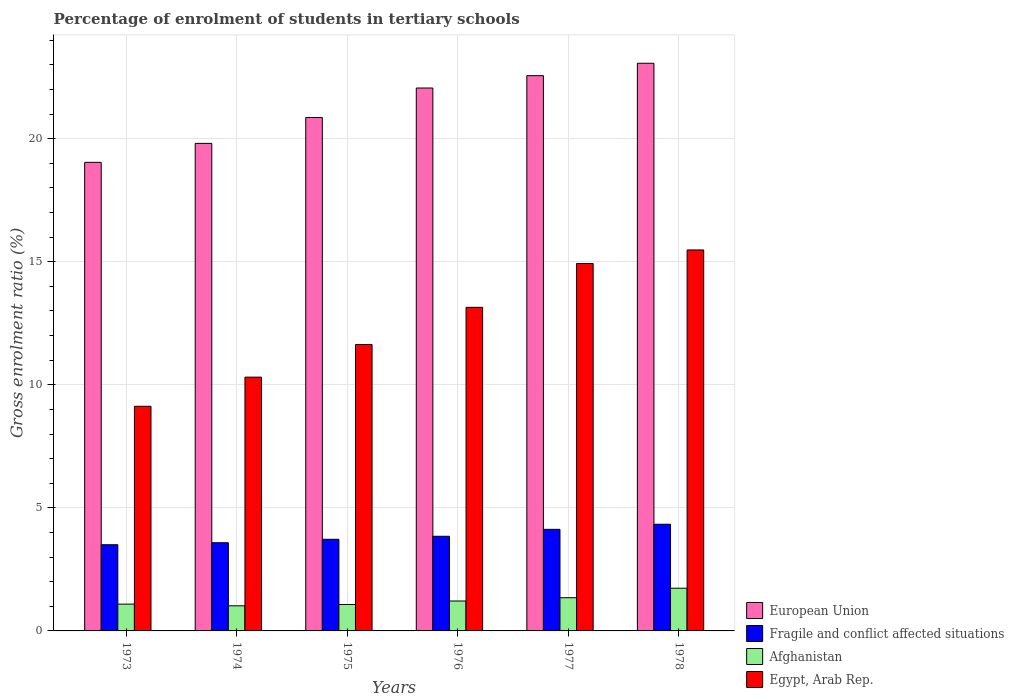How many different coloured bars are there?
Give a very brief answer. 4. How many bars are there on the 2nd tick from the left?
Provide a succinct answer. 4. What is the label of the 5th group of bars from the left?
Offer a terse response. 1977. In how many cases, is the number of bars for a given year not equal to the number of legend labels?
Your response must be concise. 0. What is the percentage of students enrolled in tertiary schools in European Union in 1973?
Your response must be concise. 19.04. Across all years, what is the maximum percentage of students enrolled in tertiary schools in European Union?
Offer a very short reply. 23.07. Across all years, what is the minimum percentage of students enrolled in tertiary schools in Afghanistan?
Provide a short and direct response. 1.02. In which year was the percentage of students enrolled in tertiary schools in Afghanistan maximum?
Provide a succinct answer. 1978. What is the total percentage of students enrolled in tertiary schools in Afghanistan in the graph?
Give a very brief answer. 7.48. What is the difference between the percentage of students enrolled in tertiary schools in European Union in 1974 and that in 1977?
Ensure brevity in your answer.  -2.75. What is the difference between the percentage of students enrolled in tertiary schools in European Union in 1977 and the percentage of students enrolled in tertiary schools in Fragile and conflict affected situations in 1974?
Offer a very short reply. 18.98. What is the average percentage of students enrolled in tertiary schools in Afghanistan per year?
Provide a short and direct response. 1.25. In the year 1974, what is the difference between the percentage of students enrolled in tertiary schools in Egypt, Arab Rep. and percentage of students enrolled in tertiary schools in Afghanistan?
Make the answer very short. 9.29. In how many years, is the percentage of students enrolled in tertiary schools in Egypt, Arab Rep. greater than 2 %?
Your answer should be very brief. 6. What is the ratio of the percentage of students enrolled in tertiary schools in Fragile and conflict affected situations in 1973 to that in 1974?
Keep it short and to the point. 0.98. Is the difference between the percentage of students enrolled in tertiary schools in Egypt, Arab Rep. in 1976 and 1977 greater than the difference between the percentage of students enrolled in tertiary schools in Afghanistan in 1976 and 1977?
Provide a succinct answer. No. What is the difference between the highest and the second highest percentage of students enrolled in tertiary schools in Egypt, Arab Rep.?
Offer a terse response. 0.55. What is the difference between the highest and the lowest percentage of students enrolled in tertiary schools in Fragile and conflict affected situations?
Keep it short and to the point. 0.83. Is the sum of the percentage of students enrolled in tertiary schools in Egypt, Arab Rep. in 1973 and 1976 greater than the maximum percentage of students enrolled in tertiary schools in Fragile and conflict affected situations across all years?
Offer a terse response. Yes. What does the 2nd bar from the left in 1974 represents?
Your response must be concise. Fragile and conflict affected situations. What does the 4th bar from the right in 1975 represents?
Your response must be concise. European Union. Are all the bars in the graph horizontal?
Your response must be concise. No. What is the difference between two consecutive major ticks on the Y-axis?
Ensure brevity in your answer.  5. Are the values on the major ticks of Y-axis written in scientific E-notation?
Make the answer very short. No. Does the graph contain any zero values?
Make the answer very short. No. Where does the legend appear in the graph?
Your answer should be compact. Bottom right. What is the title of the graph?
Your answer should be compact. Percentage of enrolment of students in tertiary schools. What is the label or title of the X-axis?
Offer a terse response. Years. What is the label or title of the Y-axis?
Offer a very short reply. Gross enrolment ratio (%). What is the Gross enrolment ratio (%) in European Union in 1973?
Provide a short and direct response. 19.04. What is the Gross enrolment ratio (%) in Fragile and conflict affected situations in 1973?
Offer a very short reply. 3.5. What is the Gross enrolment ratio (%) in Afghanistan in 1973?
Provide a succinct answer. 1.09. What is the Gross enrolment ratio (%) of Egypt, Arab Rep. in 1973?
Give a very brief answer. 9.13. What is the Gross enrolment ratio (%) of European Union in 1974?
Offer a very short reply. 19.81. What is the Gross enrolment ratio (%) in Fragile and conflict affected situations in 1974?
Your answer should be very brief. 3.58. What is the Gross enrolment ratio (%) of Afghanistan in 1974?
Offer a terse response. 1.02. What is the Gross enrolment ratio (%) of Egypt, Arab Rep. in 1974?
Your answer should be compact. 10.31. What is the Gross enrolment ratio (%) of European Union in 1975?
Your answer should be compact. 20.86. What is the Gross enrolment ratio (%) in Fragile and conflict affected situations in 1975?
Keep it short and to the point. 3.72. What is the Gross enrolment ratio (%) of Afghanistan in 1975?
Your answer should be very brief. 1.07. What is the Gross enrolment ratio (%) of Egypt, Arab Rep. in 1975?
Your response must be concise. 11.64. What is the Gross enrolment ratio (%) of European Union in 1976?
Your response must be concise. 22.06. What is the Gross enrolment ratio (%) in Fragile and conflict affected situations in 1976?
Make the answer very short. 3.85. What is the Gross enrolment ratio (%) in Afghanistan in 1976?
Your answer should be very brief. 1.22. What is the Gross enrolment ratio (%) in Egypt, Arab Rep. in 1976?
Make the answer very short. 13.15. What is the Gross enrolment ratio (%) of European Union in 1977?
Offer a very short reply. 22.56. What is the Gross enrolment ratio (%) in Fragile and conflict affected situations in 1977?
Keep it short and to the point. 4.13. What is the Gross enrolment ratio (%) of Afghanistan in 1977?
Provide a short and direct response. 1.35. What is the Gross enrolment ratio (%) in Egypt, Arab Rep. in 1977?
Give a very brief answer. 14.93. What is the Gross enrolment ratio (%) in European Union in 1978?
Give a very brief answer. 23.07. What is the Gross enrolment ratio (%) in Fragile and conflict affected situations in 1978?
Offer a terse response. 4.33. What is the Gross enrolment ratio (%) of Afghanistan in 1978?
Ensure brevity in your answer.  1.74. What is the Gross enrolment ratio (%) in Egypt, Arab Rep. in 1978?
Provide a short and direct response. 15.48. Across all years, what is the maximum Gross enrolment ratio (%) in European Union?
Your response must be concise. 23.07. Across all years, what is the maximum Gross enrolment ratio (%) in Fragile and conflict affected situations?
Provide a short and direct response. 4.33. Across all years, what is the maximum Gross enrolment ratio (%) of Afghanistan?
Keep it short and to the point. 1.74. Across all years, what is the maximum Gross enrolment ratio (%) of Egypt, Arab Rep.?
Give a very brief answer. 15.48. Across all years, what is the minimum Gross enrolment ratio (%) of European Union?
Keep it short and to the point. 19.04. Across all years, what is the minimum Gross enrolment ratio (%) in Fragile and conflict affected situations?
Ensure brevity in your answer.  3.5. Across all years, what is the minimum Gross enrolment ratio (%) of Afghanistan?
Offer a very short reply. 1.02. Across all years, what is the minimum Gross enrolment ratio (%) of Egypt, Arab Rep.?
Give a very brief answer. 9.13. What is the total Gross enrolment ratio (%) of European Union in the graph?
Provide a short and direct response. 127.4. What is the total Gross enrolment ratio (%) of Fragile and conflict affected situations in the graph?
Provide a short and direct response. 23.12. What is the total Gross enrolment ratio (%) in Afghanistan in the graph?
Your response must be concise. 7.48. What is the total Gross enrolment ratio (%) of Egypt, Arab Rep. in the graph?
Your answer should be very brief. 74.64. What is the difference between the Gross enrolment ratio (%) of European Union in 1973 and that in 1974?
Your answer should be compact. -0.77. What is the difference between the Gross enrolment ratio (%) of Fragile and conflict affected situations in 1973 and that in 1974?
Provide a succinct answer. -0.08. What is the difference between the Gross enrolment ratio (%) of Afghanistan in 1973 and that in 1974?
Ensure brevity in your answer.  0.07. What is the difference between the Gross enrolment ratio (%) of Egypt, Arab Rep. in 1973 and that in 1974?
Offer a very short reply. -1.18. What is the difference between the Gross enrolment ratio (%) in European Union in 1973 and that in 1975?
Ensure brevity in your answer.  -1.82. What is the difference between the Gross enrolment ratio (%) of Fragile and conflict affected situations in 1973 and that in 1975?
Provide a succinct answer. -0.22. What is the difference between the Gross enrolment ratio (%) in Afghanistan in 1973 and that in 1975?
Give a very brief answer. 0.02. What is the difference between the Gross enrolment ratio (%) in Egypt, Arab Rep. in 1973 and that in 1975?
Your answer should be compact. -2.51. What is the difference between the Gross enrolment ratio (%) of European Union in 1973 and that in 1976?
Your response must be concise. -3.02. What is the difference between the Gross enrolment ratio (%) in Fragile and conflict affected situations in 1973 and that in 1976?
Make the answer very short. -0.34. What is the difference between the Gross enrolment ratio (%) in Afghanistan in 1973 and that in 1976?
Give a very brief answer. -0.13. What is the difference between the Gross enrolment ratio (%) in Egypt, Arab Rep. in 1973 and that in 1976?
Provide a short and direct response. -4.02. What is the difference between the Gross enrolment ratio (%) of European Union in 1973 and that in 1977?
Ensure brevity in your answer.  -3.52. What is the difference between the Gross enrolment ratio (%) in Fragile and conflict affected situations in 1973 and that in 1977?
Provide a short and direct response. -0.62. What is the difference between the Gross enrolment ratio (%) in Afghanistan in 1973 and that in 1977?
Provide a succinct answer. -0.26. What is the difference between the Gross enrolment ratio (%) in Egypt, Arab Rep. in 1973 and that in 1977?
Your response must be concise. -5.8. What is the difference between the Gross enrolment ratio (%) of European Union in 1973 and that in 1978?
Offer a very short reply. -4.03. What is the difference between the Gross enrolment ratio (%) of Fragile and conflict affected situations in 1973 and that in 1978?
Offer a terse response. -0.83. What is the difference between the Gross enrolment ratio (%) of Afghanistan in 1973 and that in 1978?
Offer a very short reply. -0.65. What is the difference between the Gross enrolment ratio (%) in Egypt, Arab Rep. in 1973 and that in 1978?
Provide a succinct answer. -6.35. What is the difference between the Gross enrolment ratio (%) of European Union in 1974 and that in 1975?
Offer a terse response. -1.05. What is the difference between the Gross enrolment ratio (%) in Fragile and conflict affected situations in 1974 and that in 1975?
Your answer should be very brief. -0.14. What is the difference between the Gross enrolment ratio (%) of Afghanistan in 1974 and that in 1975?
Provide a short and direct response. -0.05. What is the difference between the Gross enrolment ratio (%) of Egypt, Arab Rep. in 1974 and that in 1975?
Provide a succinct answer. -1.33. What is the difference between the Gross enrolment ratio (%) in European Union in 1974 and that in 1976?
Your answer should be compact. -2.25. What is the difference between the Gross enrolment ratio (%) of Fragile and conflict affected situations in 1974 and that in 1976?
Provide a succinct answer. -0.26. What is the difference between the Gross enrolment ratio (%) of Afghanistan in 1974 and that in 1976?
Provide a succinct answer. -0.2. What is the difference between the Gross enrolment ratio (%) in Egypt, Arab Rep. in 1974 and that in 1976?
Your answer should be very brief. -2.84. What is the difference between the Gross enrolment ratio (%) in European Union in 1974 and that in 1977?
Offer a very short reply. -2.75. What is the difference between the Gross enrolment ratio (%) of Fragile and conflict affected situations in 1974 and that in 1977?
Your answer should be very brief. -0.54. What is the difference between the Gross enrolment ratio (%) of Afghanistan in 1974 and that in 1977?
Provide a succinct answer. -0.33. What is the difference between the Gross enrolment ratio (%) of Egypt, Arab Rep. in 1974 and that in 1977?
Offer a terse response. -4.62. What is the difference between the Gross enrolment ratio (%) in European Union in 1974 and that in 1978?
Keep it short and to the point. -3.26. What is the difference between the Gross enrolment ratio (%) of Fragile and conflict affected situations in 1974 and that in 1978?
Provide a short and direct response. -0.75. What is the difference between the Gross enrolment ratio (%) of Afghanistan in 1974 and that in 1978?
Offer a terse response. -0.72. What is the difference between the Gross enrolment ratio (%) in Egypt, Arab Rep. in 1974 and that in 1978?
Ensure brevity in your answer.  -5.17. What is the difference between the Gross enrolment ratio (%) of European Union in 1975 and that in 1976?
Your answer should be very brief. -1.2. What is the difference between the Gross enrolment ratio (%) in Fragile and conflict affected situations in 1975 and that in 1976?
Your answer should be compact. -0.12. What is the difference between the Gross enrolment ratio (%) of Afghanistan in 1975 and that in 1976?
Make the answer very short. -0.14. What is the difference between the Gross enrolment ratio (%) in Egypt, Arab Rep. in 1975 and that in 1976?
Your answer should be compact. -1.51. What is the difference between the Gross enrolment ratio (%) of European Union in 1975 and that in 1977?
Your answer should be compact. -1.7. What is the difference between the Gross enrolment ratio (%) of Fragile and conflict affected situations in 1975 and that in 1977?
Ensure brevity in your answer.  -0.4. What is the difference between the Gross enrolment ratio (%) of Afghanistan in 1975 and that in 1977?
Keep it short and to the point. -0.28. What is the difference between the Gross enrolment ratio (%) in Egypt, Arab Rep. in 1975 and that in 1977?
Offer a terse response. -3.29. What is the difference between the Gross enrolment ratio (%) of European Union in 1975 and that in 1978?
Provide a succinct answer. -2.2. What is the difference between the Gross enrolment ratio (%) in Fragile and conflict affected situations in 1975 and that in 1978?
Make the answer very short. -0.61. What is the difference between the Gross enrolment ratio (%) of Afghanistan in 1975 and that in 1978?
Your answer should be compact. -0.66. What is the difference between the Gross enrolment ratio (%) in Egypt, Arab Rep. in 1975 and that in 1978?
Offer a terse response. -3.84. What is the difference between the Gross enrolment ratio (%) in European Union in 1976 and that in 1977?
Your response must be concise. -0.5. What is the difference between the Gross enrolment ratio (%) in Fragile and conflict affected situations in 1976 and that in 1977?
Offer a terse response. -0.28. What is the difference between the Gross enrolment ratio (%) in Afghanistan in 1976 and that in 1977?
Keep it short and to the point. -0.13. What is the difference between the Gross enrolment ratio (%) in Egypt, Arab Rep. in 1976 and that in 1977?
Your answer should be compact. -1.78. What is the difference between the Gross enrolment ratio (%) in European Union in 1976 and that in 1978?
Keep it short and to the point. -1.01. What is the difference between the Gross enrolment ratio (%) in Fragile and conflict affected situations in 1976 and that in 1978?
Your answer should be compact. -0.49. What is the difference between the Gross enrolment ratio (%) of Afghanistan in 1976 and that in 1978?
Provide a short and direct response. -0.52. What is the difference between the Gross enrolment ratio (%) in Egypt, Arab Rep. in 1976 and that in 1978?
Your answer should be very brief. -2.33. What is the difference between the Gross enrolment ratio (%) in European Union in 1977 and that in 1978?
Make the answer very short. -0.5. What is the difference between the Gross enrolment ratio (%) of Fragile and conflict affected situations in 1977 and that in 1978?
Provide a succinct answer. -0.21. What is the difference between the Gross enrolment ratio (%) in Afghanistan in 1977 and that in 1978?
Provide a succinct answer. -0.39. What is the difference between the Gross enrolment ratio (%) in Egypt, Arab Rep. in 1977 and that in 1978?
Make the answer very short. -0.55. What is the difference between the Gross enrolment ratio (%) in European Union in 1973 and the Gross enrolment ratio (%) in Fragile and conflict affected situations in 1974?
Your answer should be very brief. 15.46. What is the difference between the Gross enrolment ratio (%) in European Union in 1973 and the Gross enrolment ratio (%) in Afghanistan in 1974?
Your answer should be very brief. 18.02. What is the difference between the Gross enrolment ratio (%) in European Union in 1973 and the Gross enrolment ratio (%) in Egypt, Arab Rep. in 1974?
Your answer should be very brief. 8.73. What is the difference between the Gross enrolment ratio (%) of Fragile and conflict affected situations in 1973 and the Gross enrolment ratio (%) of Afghanistan in 1974?
Provide a succinct answer. 2.48. What is the difference between the Gross enrolment ratio (%) of Fragile and conflict affected situations in 1973 and the Gross enrolment ratio (%) of Egypt, Arab Rep. in 1974?
Your response must be concise. -6.81. What is the difference between the Gross enrolment ratio (%) in Afghanistan in 1973 and the Gross enrolment ratio (%) in Egypt, Arab Rep. in 1974?
Your response must be concise. -9.22. What is the difference between the Gross enrolment ratio (%) of European Union in 1973 and the Gross enrolment ratio (%) of Fragile and conflict affected situations in 1975?
Your response must be concise. 15.32. What is the difference between the Gross enrolment ratio (%) in European Union in 1973 and the Gross enrolment ratio (%) in Afghanistan in 1975?
Your answer should be very brief. 17.97. What is the difference between the Gross enrolment ratio (%) in European Union in 1973 and the Gross enrolment ratio (%) in Egypt, Arab Rep. in 1975?
Make the answer very short. 7.4. What is the difference between the Gross enrolment ratio (%) of Fragile and conflict affected situations in 1973 and the Gross enrolment ratio (%) of Afghanistan in 1975?
Provide a succinct answer. 2.43. What is the difference between the Gross enrolment ratio (%) in Fragile and conflict affected situations in 1973 and the Gross enrolment ratio (%) in Egypt, Arab Rep. in 1975?
Your answer should be very brief. -8.13. What is the difference between the Gross enrolment ratio (%) in Afghanistan in 1973 and the Gross enrolment ratio (%) in Egypt, Arab Rep. in 1975?
Provide a short and direct response. -10.55. What is the difference between the Gross enrolment ratio (%) in European Union in 1973 and the Gross enrolment ratio (%) in Fragile and conflict affected situations in 1976?
Your response must be concise. 15.19. What is the difference between the Gross enrolment ratio (%) in European Union in 1973 and the Gross enrolment ratio (%) in Afghanistan in 1976?
Provide a succinct answer. 17.82. What is the difference between the Gross enrolment ratio (%) of European Union in 1973 and the Gross enrolment ratio (%) of Egypt, Arab Rep. in 1976?
Your response must be concise. 5.89. What is the difference between the Gross enrolment ratio (%) of Fragile and conflict affected situations in 1973 and the Gross enrolment ratio (%) of Afghanistan in 1976?
Your answer should be very brief. 2.29. What is the difference between the Gross enrolment ratio (%) in Fragile and conflict affected situations in 1973 and the Gross enrolment ratio (%) in Egypt, Arab Rep. in 1976?
Provide a short and direct response. -9.65. What is the difference between the Gross enrolment ratio (%) of Afghanistan in 1973 and the Gross enrolment ratio (%) of Egypt, Arab Rep. in 1976?
Your answer should be very brief. -12.06. What is the difference between the Gross enrolment ratio (%) in European Union in 1973 and the Gross enrolment ratio (%) in Fragile and conflict affected situations in 1977?
Ensure brevity in your answer.  14.91. What is the difference between the Gross enrolment ratio (%) of European Union in 1973 and the Gross enrolment ratio (%) of Afghanistan in 1977?
Provide a short and direct response. 17.69. What is the difference between the Gross enrolment ratio (%) of European Union in 1973 and the Gross enrolment ratio (%) of Egypt, Arab Rep. in 1977?
Provide a succinct answer. 4.11. What is the difference between the Gross enrolment ratio (%) in Fragile and conflict affected situations in 1973 and the Gross enrolment ratio (%) in Afghanistan in 1977?
Make the answer very short. 2.15. What is the difference between the Gross enrolment ratio (%) in Fragile and conflict affected situations in 1973 and the Gross enrolment ratio (%) in Egypt, Arab Rep. in 1977?
Offer a terse response. -11.43. What is the difference between the Gross enrolment ratio (%) of Afghanistan in 1973 and the Gross enrolment ratio (%) of Egypt, Arab Rep. in 1977?
Your response must be concise. -13.84. What is the difference between the Gross enrolment ratio (%) in European Union in 1973 and the Gross enrolment ratio (%) in Fragile and conflict affected situations in 1978?
Offer a very short reply. 14.71. What is the difference between the Gross enrolment ratio (%) of European Union in 1973 and the Gross enrolment ratio (%) of Afghanistan in 1978?
Provide a short and direct response. 17.3. What is the difference between the Gross enrolment ratio (%) of European Union in 1973 and the Gross enrolment ratio (%) of Egypt, Arab Rep. in 1978?
Give a very brief answer. 3.56. What is the difference between the Gross enrolment ratio (%) in Fragile and conflict affected situations in 1973 and the Gross enrolment ratio (%) in Afghanistan in 1978?
Your response must be concise. 1.77. What is the difference between the Gross enrolment ratio (%) of Fragile and conflict affected situations in 1973 and the Gross enrolment ratio (%) of Egypt, Arab Rep. in 1978?
Provide a succinct answer. -11.98. What is the difference between the Gross enrolment ratio (%) of Afghanistan in 1973 and the Gross enrolment ratio (%) of Egypt, Arab Rep. in 1978?
Your answer should be compact. -14.39. What is the difference between the Gross enrolment ratio (%) in European Union in 1974 and the Gross enrolment ratio (%) in Fragile and conflict affected situations in 1975?
Keep it short and to the point. 16.09. What is the difference between the Gross enrolment ratio (%) of European Union in 1974 and the Gross enrolment ratio (%) of Afghanistan in 1975?
Give a very brief answer. 18.74. What is the difference between the Gross enrolment ratio (%) of European Union in 1974 and the Gross enrolment ratio (%) of Egypt, Arab Rep. in 1975?
Keep it short and to the point. 8.17. What is the difference between the Gross enrolment ratio (%) in Fragile and conflict affected situations in 1974 and the Gross enrolment ratio (%) in Afghanistan in 1975?
Give a very brief answer. 2.51. What is the difference between the Gross enrolment ratio (%) of Fragile and conflict affected situations in 1974 and the Gross enrolment ratio (%) of Egypt, Arab Rep. in 1975?
Provide a succinct answer. -8.05. What is the difference between the Gross enrolment ratio (%) in Afghanistan in 1974 and the Gross enrolment ratio (%) in Egypt, Arab Rep. in 1975?
Provide a succinct answer. -10.62. What is the difference between the Gross enrolment ratio (%) of European Union in 1974 and the Gross enrolment ratio (%) of Fragile and conflict affected situations in 1976?
Keep it short and to the point. 15.96. What is the difference between the Gross enrolment ratio (%) of European Union in 1974 and the Gross enrolment ratio (%) of Afghanistan in 1976?
Give a very brief answer. 18.6. What is the difference between the Gross enrolment ratio (%) in European Union in 1974 and the Gross enrolment ratio (%) in Egypt, Arab Rep. in 1976?
Ensure brevity in your answer.  6.66. What is the difference between the Gross enrolment ratio (%) of Fragile and conflict affected situations in 1974 and the Gross enrolment ratio (%) of Afghanistan in 1976?
Your response must be concise. 2.37. What is the difference between the Gross enrolment ratio (%) in Fragile and conflict affected situations in 1974 and the Gross enrolment ratio (%) in Egypt, Arab Rep. in 1976?
Your response must be concise. -9.57. What is the difference between the Gross enrolment ratio (%) in Afghanistan in 1974 and the Gross enrolment ratio (%) in Egypt, Arab Rep. in 1976?
Provide a short and direct response. -12.13. What is the difference between the Gross enrolment ratio (%) of European Union in 1974 and the Gross enrolment ratio (%) of Fragile and conflict affected situations in 1977?
Offer a very short reply. 15.68. What is the difference between the Gross enrolment ratio (%) in European Union in 1974 and the Gross enrolment ratio (%) in Afghanistan in 1977?
Provide a short and direct response. 18.46. What is the difference between the Gross enrolment ratio (%) in European Union in 1974 and the Gross enrolment ratio (%) in Egypt, Arab Rep. in 1977?
Offer a terse response. 4.88. What is the difference between the Gross enrolment ratio (%) in Fragile and conflict affected situations in 1974 and the Gross enrolment ratio (%) in Afghanistan in 1977?
Your answer should be compact. 2.23. What is the difference between the Gross enrolment ratio (%) in Fragile and conflict affected situations in 1974 and the Gross enrolment ratio (%) in Egypt, Arab Rep. in 1977?
Your response must be concise. -11.35. What is the difference between the Gross enrolment ratio (%) in Afghanistan in 1974 and the Gross enrolment ratio (%) in Egypt, Arab Rep. in 1977?
Your response must be concise. -13.91. What is the difference between the Gross enrolment ratio (%) of European Union in 1974 and the Gross enrolment ratio (%) of Fragile and conflict affected situations in 1978?
Make the answer very short. 15.48. What is the difference between the Gross enrolment ratio (%) of European Union in 1974 and the Gross enrolment ratio (%) of Afghanistan in 1978?
Your answer should be compact. 18.08. What is the difference between the Gross enrolment ratio (%) of European Union in 1974 and the Gross enrolment ratio (%) of Egypt, Arab Rep. in 1978?
Give a very brief answer. 4.33. What is the difference between the Gross enrolment ratio (%) in Fragile and conflict affected situations in 1974 and the Gross enrolment ratio (%) in Afghanistan in 1978?
Your answer should be compact. 1.85. What is the difference between the Gross enrolment ratio (%) of Fragile and conflict affected situations in 1974 and the Gross enrolment ratio (%) of Egypt, Arab Rep. in 1978?
Offer a very short reply. -11.9. What is the difference between the Gross enrolment ratio (%) in Afghanistan in 1974 and the Gross enrolment ratio (%) in Egypt, Arab Rep. in 1978?
Offer a very short reply. -14.46. What is the difference between the Gross enrolment ratio (%) in European Union in 1975 and the Gross enrolment ratio (%) in Fragile and conflict affected situations in 1976?
Your response must be concise. 17.02. What is the difference between the Gross enrolment ratio (%) in European Union in 1975 and the Gross enrolment ratio (%) in Afghanistan in 1976?
Give a very brief answer. 19.65. What is the difference between the Gross enrolment ratio (%) in European Union in 1975 and the Gross enrolment ratio (%) in Egypt, Arab Rep. in 1976?
Give a very brief answer. 7.71. What is the difference between the Gross enrolment ratio (%) of Fragile and conflict affected situations in 1975 and the Gross enrolment ratio (%) of Afghanistan in 1976?
Keep it short and to the point. 2.51. What is the difference between the Gross enrolment ratio (%) of Fragile and conflict affected situations in 1975 and the Gross enrolment ratio (%) of Egypt, Arab Rep. in 1976?
Ensure brevity in your answer.  -9.42. What is the difference between the Gross enrolment ratio (%) in Afghanistan in 1975 and the Gross enrolment ratio (%) in Egypt, Arab Rep. in 1976?
Give a very brief answer. -12.07. What is the difference between the Gross enrolment ratio (%) of European Union in 1975 and the Gross enrolment ratio (%) of Fragile and conflict affected situations in 1977?
Your response must be concise. 16.74. What is the difference between the Gross enrolment ratio (%) of European Union in 1975 and the Gross enrolment ratio (%) of Afghanistan in 1977?
Your answer should be compact. 19.51. What is the difference between the Gross enrolment ratio (%) of European Union in 1975 and the Gross enrolment ratio (%) of Egypt, Arab Rep. in 1977?
Provide a short and direct response. 5.93. What is the difference between the Gross enrolment ratio (%) in Fragile and conflict affected situations in 1975 and the Gross enrolment ratio (%) in Afghanistan in 1977?
Ensure brevity in your answer.  2.37. What is the difference between the Gross enrolment ratio (%) in Fragile and conflict affected situations in 1975 and the Gross enrolment ratio (%) in Egypt, Arab Rep. in 1977?
Provide a short and direct response. -11.21. What is the difference between the Gross enrolment ratio (%) in Afghanistan in 1975 and the Gross enrolment ratio (%) in Egypt, Arab Rep. in 1977?
Keep it short and to the point. -13.86. What is the difference between the Gross enrolment ratio (%) of European Union in 1975 and the Gross enrolment ratio (%) of Fragile and conflict affected situations in 1978?
Offer a terse response. 16.53. What is the difference between the Gross enrolment ratio (%) of European Union in 1975 and the Gross enrolment ratio (%) of Afghanistan in 1978?
Offer a very short reply. 19.13. What is the difference between the Gross enrolment ratio (%) of European Union in 1975 and the Gross enrolment ratio (%) of Egypt, Arab Rep. in 1978?
Provide a short and direct response. 5.38. What is the difference between the Gross enrolment ratio (%) of Fragile and conflict affected situations in 1975 and the Gross enrolment ratio (%) of Afghanistan in 1978?
Your answer should be compact. 1.99. What is the difference between the Gross enrolment ratio (%) of Fragile and conflict affected situations in 1975 and the Gross enrolment ratio (%) of Egypt, Arab Rep. in 1978?
Give a very brief answer. -11.76. What is the difference between the Gross enrolment ratio (%) in Afghanistan in 1975 and the Gross enrolment ratio (%) in Egypt, Arab Rep. in 1978?
Make the answer very short. -14.41. What is the difference between the Gross enrolment ratio (%) in European Union in 1976 and the Gross enrolment ratio (%) in Fragile and conflict affected situations in 1977?
Your response must be concise. 17.93. What is the difference between the Gross enrolment ratio (%) of European Union in 1976 and the Gross enrolment ratio (%) of Afghanistan in 1977?
Make the answer very short. 20.71. What is the difference between the Gross enrolment ratio (%) of European Union in 1976 and the Gross enrolment ratio (%) of Egypt, Arab Rep. in 1977?
Offer a very short reply. 7.13. What is the difference between the Gross enrolment ratio (%) of Fragile and conflict affected situations in 1976 and the Gross enrolment ratio (%) of Afghanistan in 1977?
Keep it short and to the point. 2.5. What is the difference between the Gross enrolment ratio (%) in Fragile and conflict affected situations in 1976 and the Gross enrolment ratio (%) in Egypt, Arab Rep. in 1977?
Keep it short and to the point. -11.08. What is the difference between the Gross enrolment ratio (%) of Afghanistan in 1976 and the Gross enrolment ratio (%) of Egypt, Arab Rep. in 1977?
Your answer should be very brief. -13.71. What is the difference between the Gross enrolment ratio (%) of European Union in 1976 and the Gross enrolment ratio (%) of Fragile and conflict affected situations in 1978?
Keep it short and to the point. 17.73. What is the difference between the Gross enrolment ratio (%) in European Union in 1976 and the Gross enrolment ratio (%) in Afghanistan in 1978?
Make the answer very short. 20.33. What is the difference between the Gross enrolment ratio (%) in European Union in 1976 and the Gross enrolment ratio (%) in Egypt, Arab Rep. in 1978?
Provide a short and direct response. 6.58. What is the difference between the Gross enrolment ratio (%) in Fragile and conflict affected situations in 1976 and the Gross enrolment ratio (%) in Afghanistan in 1978?
Your response must be concise. 2.11. What is the difference between the Gross enrolment ratio (%) in Fragile and conflict affected situations in 1976 and the Gross enrolment ratio (%) in Egypt, Arab Rep. in 1978?
Your answer should be very brief. -11.63. What is the difference between the Gross enrolment ratio (%) of Afghanistan in 1976 and the Gross enrolment ratio (%) of Egypt, Arab Rep. in 1978?
Offer a very short reply. -14.27. What is the difference between the Gross enrolment ratio (%) in European Union in 1977 and the Gross enrolment ratio (%) in Fragile and conflict affected situations in 1978?
Offer a terse response. 18.23. What is the difference between the Gross enrolment ratio (%) of European Union in 1977 and the Gross enrolment ratio (%) of Afghanistan in 1978?
Provide a succinct answer. 20.83. What is the difference between the Gross enrolment ratio (%) of European Union in 1977 and the Gross enrolment ratio (%) of Egypt, Arab Rep. in 1978?
Offer a very short reply. 7.08. What is the difference between the Gross enrolment ratio (%) in Fragile and conflict affected situations in 1977 and the Gross enrolment ratio (%) in Afghanistan in 1978?
Your response must be concise. 2.39. What is the difference between the Gross enrolment ratio (%) of Fragile and conflict affected situations in 1977 and the Gross enrolment ratio (%) of Egypt, Arab Rep. in 1978?
Your answer should be very brief. -11.35. What is the difference between the Gross enrolment ratio (%) in Afghanistan in 1977 and the Gross enrolment ratio (%) in Egypt, Arab Rep. in 1978?
Ensure brevity in your answer.  -14.13. What is the average Gross enrolment ratio (%) of European Union per year?
Ensure brevity in your answer.  21.23. What is the average Gross enrolment ratio (%) in Fragile and conflict affected situations per year?
Offer a terse response. 3.85. What is the average Gross enrolment ratio (%) in Afghanistan per year?
Your answer should be very brief. 1.25. What is the average Gross enrolment ratio (%) in Egypt, Arab Rep. per year?
Give a very brief answer. 12.44. In the year 1973, what is the difference between the Gross enrolment ratio (%) of European Union and Gross enrolment ratio (%) of Fragile and conflict affected situations?
Offer a terse response. 15.54. In the year 1973, what is the difference between the Gross enrolment ratio (%) of European Union and Gross enrolment ratio (%) of Afghanistan?
Your answer should be very brief. 17.95. In the year 1973, what is the difference between the Gross enrolment ratio (%) of European Union and Gross enrolment ratio (%) of Egypt, Arab Rep.?
Your answer should be compact. 9.91. In the year 1973, what is the difference between the Gross enrolment ratio (%) of Fragile and conflict affected situations and Gross enrolment ratio (%) of Afghanistan?
Give a very brief answer. 2.41. In the year 1973, what is the difference between the Gross enrolment ratio (%) in Fragile and conflict affected situations and Gross enrolment ratio (%) in Egypt, Arab Rep.?
Your answer should be very brief. -5.63. In the year 1973, what is the difference between the Gross enrolment ratio (%) in Afghanistan and Gross enrolment ratio (%) in Egypt, Arab Rep.?
Give a very brief answer. -8.04. In the year 1974, what is the difference between the Gross enrolment ratio (%) of European Union and Gross enrolment ratio (%) of Fragile and conflict affected situations?
Provide a succinct answer. 16.23. In the year 1974, what is the difference between the Gross enrolment ratio (%) in European Union and Gross enrolment ratio (%) in Afghanistan?
Your answer should be very brief. 18.79. In the year 1974, what is the difference between the Gross enrolment ratio (%) of European Union and Gross enrolment ratio (%) of Egypt, Arab Rep.?
Provide a short and direct response. 9.5. In the year 1974, what is the difference between the Gross enrolment ratio (%) of Fragile and conflict affected situations and Gross enrolment ratio (%) of Afghanistan?
Ensure brevity in your answer.  2.56. In the year 1974, what is the difference between the Gross enrolment ratio (%) of Fragile and conflict affected situations and Gross enrolment ratio (%) of Egypt, Arab Rep.?
Ensure brevity in your answer.  -6.73. In the year 1974, what is the difference between the Gross enrolment ratio (%) of Afghanistan and Gross enrolment ratio (%) of Egypt, Arab Rep.?
Your answer should be compact. -9.29. In the year 1975, what is the difference between the Gross enrolment ratio (%) of European Union and Gross enrolment ratio (%) of Fragile and conflict affected situations?
Ensure brevity in your answer.  17.14. In the year 1975, what is the difference between the Gross enrolment ratio (%) in European Union and Gross enrolment ratio (%) in Afghanistan?
Provide a succinct answer. 19.79. In the year 1975, what is the difference between the Gross enrolment ratio (%) in European Union and Gross enrolment ratio (%) in Egypt, Arab Rep.?
Your answer should be very brief. 9.23. In the year 1975, what is the difference between the Gross enrolment ratio (%) of Fragile and conflict affected situations and Gross enrolment ratio (%) of Afghanistan?
Your answer should be very brief. 2.65. In the year 1975, what is the difference between the Gross enrolment ratio (%) of Fragile and conflict affected situations and Gross enrolment ratio (%) of Egypt, Arab Rep.?
Ensure brevity in your answer.  -7.91. In the year 1975, what is the difference between the Gross enrolment ratio (%) of Afghanistan and Gross enrolment ratio (%) of Egypt, Arab Rep.?
Your answer should be very brief. -10.56. In the year 1976, what is the difference between the Gross enrolment ratio (%) of European Union and Gross enrolment ratio (%) of Fragile and conflict affected situations?
Give a very brief answer. 18.21. In the year 1976, what is the difference between the Gross enrolment ratio (%) in European Union and Gross enrolment ratio (%) in Afghanistan?
Provide a succinct answer. 20.85. In the year 1976, what is the difference between the Gross enrolment ratio (%) of European Union and Gross enrolment ratio (%) of Egypt, Arab Rep.?
Ensure brevity in your answer.  8.91. In the year 1976, what is the difference between the Gross enrolment ratio (%) of Fragile and conflict affected situations and Gross enrolment ratio (%) of Afghanistan?
Provide a short and direct response. 2.63. In the year 1976, what is the difference between the Gross enrolment ratio (%) of Fragile and conflict affected situations and Gross enrolment ratio (%) of Egypt, Arab Rep.?
Your response must be concise. -9.3. In the year 1976, what is the difference between the Gross enrolment ratio (%) in Afghanistan and Gross enrolment ratio (%) in Egypt, Arab Rep.?
Make the answer very short. -11.93. In the year 1977, what is the difference between the Gross enrolment ratio (%) in European Union and Gross enrolment ratio (%) in Fragile and conflict affected situations?
Give a very brief answer. 18.43. In the year 1977, what is the difference between the Gross enrolment ratio (%) in European Union and Gross enrolment ratio (%) in Afghanistan?
Provide a succinct answer. 21.21. In the year 1977, what is the difference between the Gross enrolment ratio (%) of European Union and Gross enrolment ratio (%) of Egypt, Arab Rep.?
Offer a very short reply. 7.63. In the year 1977, what is the difference between the Gross enrolment ratio (%) of Fragile and conflict affected situations and Gross enrolment ratio (%) of Afghanistan?
Your answer should be very brief. 2.78. In the year 1977, what is the difference between the Gross enrolment ratio (%) of Fragile and conflict affected situations and Gross enrolment ratio (%) of Egypt, Arab Rep.?
Offer a very short reply. -10.8. In the year 1977, what is the difference between the Gross enrolment ratio (%) of Afghanistan and Gross enrolment ratio (%) of Egypt, Arab Rep.?
Your response must be concise. -13.58. In the year 1978, what is the difference between the Gross enrolment ratio (%) of European Union and Gross enrolment ratio (%) of Fragile and conflict affected situations?
Your response must be concise. 18.73. In the year 1978, what is the difference between the Gross enrolment ratio (%) in European Union and Gross enrolment ratio (%) in Afghanistan?
Your answer should be compact. 21.33. In the year 1978, what is the difference between the Gross enrolment ratio (%) of European Union and Gross enrolment ratio (%) of Egypt, Arab Rep.?
Keep it short and to the point. 7.59. In the year 1978, what is the difference between the Gross enrolment ratio (%) of Fragile and conflict affected situations and Gross enrolment ratio (%) of Afghanistan?
Offer a terse response. 2.6. In the year 1978, what is the difference between the Gross enrolment ratio (%) of Fragile and conflict affected situations and Gross enrolment ratio (%) of Egypt, Arab Rep.?
Keep it short and to the point. -11.15. In the year 1978, what is the difference between the Gross enrolment ratio (%) of Afghanistan and Gross enrolment ratio (%) of Egypt, Arab Rep.?
Offer a terse response. -13.75. What is the ratio of the Gross enrolment ratio (%) in European Union in 1973 to that in 1974?
Make the answer very short. 0.96. What is the ratio of the Gross enrolment ratio (%) of Fragile and conflict affected situations in 1973 to that in 1974?
Your answer should be compact. 0.98. What is the ratio of the Gross enrolment ratio (%) in Afghanistan in 1973 to that in 1974?
Make the answer very short. 1.07. What is the ratio of the Gross enrolment ratio (%) in Egypt, Arab Rep. in 1973 to that in 1974?
Keep it short and to the point. 0.89. What is the ratio of the Gross enrolment ratio (%) in European Union in 1973 to that in 1975?
Offer a terse response. 0.91. What is the ratio of the Gross enrolment ratio (%) of Fragile and conflict affected situations in 1973 to that in 1975?
Give a very brief answer. 0.94. What is the ratio of the Gross enrolment ratio (%) of Afghanistan in 1973 to that in 1975?
Your answer should be very brief. 1.01. What is the ratio of the Gross enrolment ratio (%) of Egypt, Arab Rep. in 1973 to that in 1975?
Ensure brevity in your answer.  0.78. What is the ratio of the Gross enrolment ratio (%) in European Union in 1973 to that in 1976?
Your response must be concise. 0.86. What is the ratio of the Gross enrolment ratio (%) in Fragile and conflict affected situations in 1973 to that in 1976?
Keep it short and to the point. 0.91. What is the ratio of the Gross enrolment ratio (%) of Afghanistan in 1973 to that in 1976?
Your answer should be very brief. 0.9. What is the ratio of the Gross enrolment ratio (%) of Egypt, Arab Rep. in 1973 to that in 1976?
Provide a succinct answer. 0.69. What is the ratio of the Gross enrolment ratio (%) in European Union in 1973 to that in 1977?
Offer a very short reply. 0.84. What is the ratio of the Gross enrolment ratio (%) in Fragile and conflict affected situations in 1973 to that in 1977?
Ensure brevity in your answer.  0.85. What is the ratio of the Gross enrolment ratio (%) in Afghanistan in 1973 to that in 1977?
Make the answer very short. 0.81. What is the ratio of the Gross enrolment ratio (%) of Egypt, Arab Rep. in 1973 to that in 1977?
Make the answer very short. 0.61. What is the ratio of the Gross enrolment ratio (%) of European Union in 1973 to that in 1978?
Offer a very short reply. 0.83. What is the ratio of the Gross enrolment ratio (%) of Fragile and conflict affected situations in 1973 to that in 1978?
Make the answer very short. 0.81. What is the ratio of the Gross enrolment ratio (%) in Afghanistan in 1973 to that in 1978?
Your response must be concise. 0.63. What is the ratio of the Gross enrolment ratio (%) in Egypt, Arab Rep. in 1973 to that in 1978?
Offer a terse response. 0.59. What is the ratio of the Gross enrolment ratio (%) of European Union in 1974 to that in 1975?
Offer a very short reply. 0.95. What is the ratio of the Gross enrolment ratio (%) in Fragile and conflict affected situations in 1974 to that in 1975?
Your answer should be very brief. 0.96. What is the ratio of the Gross enrolment ratio (%) of Afghanistan in 1974 to that in 1975?
Offer a very short reply. 0.95. What is the ratio of the Gross enrolment ratio (%) in Egypt, Arab Rep. in 1974 to that in 1975?
Provide a short and direct response. 0.89. What is the ratio of the Gross enrolment ratio (%) of European Union in 1974 to that in 1976?
Keep it short and to the point. 0.9. What is the ratio of the Gross enrolment ratio (%) in Fragile and conflict affected situations in 1974 to that in 1976?
Offer a very short reply. 0.93. What is the ratio of the Gross enrolment ratio (%) in Afghanistan in 1974 to that in 1976?
Your response must be concise. 0.84. What is the ratio of the Gross enrolment ratio (%) of Egypt, Arab Rep. in 1974 to that in 1976?
Your response must be concise. 0.78. What is the ratio of the Gross enrolment ratio (%) in European Union in 1974 to that in 1977?
Give a very brief answer. 0.88. What is the ratio of the Gross enrolment ratio (%) of Fragile and conflict affected situations in 1974 to that in 1977?
Your answer should be compact. 0.87. What is the ratio of the Gross enrolment ratio (%) of Afghanistan in 1974 to that in 1977?
Offer a terse response. 0.76. What is the ratio of the Gross enrolment ratio (%) of Egypt, Arab Rep. in 1974 to that in 1977?
Give a very brief answer. 0.69. What is the ratio of the Gross enrolment ratio (%) of European Union in 1974 to that in 1978?
Give a very brief answer. 0.86. What is the ratio of the Gross enrolment ratio (%) of Fragile and conflict affected situations in 1974 to that in 1978?
Offer a very short reply. 0.83. What is the ratio of the Gross enrolment ratio (%) in Afghanistan in 1974 to that in 1978?
Ensure brevity in your answer.  0.59. What is the ratio of the Gross enrolment ratio (%) in Egypt, Arab Rep. in 1974 to that in 1978?
Make the answer very short. 0.67. What is the ratio of the Gross enrolment ratio (%) in European Union in 1975 to that in 1976?
Provide a short and direct response. 0.95. What is the ratio of the Gross enrolment ratio (%) in Fragile and conflict affected situations in 1975 to that in 1976?
Offer a very short reply. 0.97. What is the ratio of the Gross enrolment ratio (%) in Afghanistan in 1975 to that in 1976?
Your response must be concise. 0.88. What is the ratio of the Gross enrolment ratio (%) in Egypt, Arab Rep. in 1975 to that in 1976?
Your answer should be very brief. 0.89. What is the ratio of the Gross enrolment ratio (%) in European Union in 1975 to that in 1977?
Give a very brief answer. 0.92. What is the ratio of the Gross enrolment ratio (%) of Fragile and conflict affected situations in 1975 to that in 1977?
Keep it short and to the point. 0.9. What is the ratio of the Gross enrolment ratio (%) of Afghanistan in 1975 to that in 1977?
Your response must be concise. 0.8. What is the ratio of the Gross enrolment ratio (%) in Egypt, Arab Rep. in 1975 to that in 1977?
Keep it short and to the point. 0.78. What is the ratio of the Gross enrolment ratio (%) of European Union in 1975 to that in 1978?
Provide a succinct answer. 0.9. What is the ratio of the Gross enrolment ratio (%) in Fragile and conflict affected situations in 1975 to that in 1978?
Give a very brief answer. 0.86. What is the ratio of the Gross enrolment ratio (%) in Afghanistan in 1975 to that in 1978?
Provide a short and direct response. 0.62. What is the ratio of the Gross enrolment ratio (%) of Egypt, Arab Rep. in 1975 to that in 1978?
Give a very brief answer. 0.75. What is the ratio of the Gross enrolment ratio (%) in European Union in 1976 to that in 1977?
Your answer should be very brief. 0.98. What is the ratio of the Gross enrolment ratio (%) of Fragile and conflict affected situations in 1976 to that in 1977?
Ensure brevity in your answer.  0.93. What is the ratio of the Gross enrolment ratio (%) in Afghanistan in 1976 to that in 1977?
Provide a short and direct response. 0.9. What is the ratio of the Gross enrolment ratio (%) in Egypt, Arab Rep. in 1976 to that in 1977?
Your answer should be very brief. 0.88. What is the ratio of the Gross enrolment ratio (%) of European Union in 1976 to that in 1978?
Offer a terse response. 0.96. What is the ratio of the Gross enrolment ratio (%) of Fragile and conflict affected situations in 1976 to that in 1978?
Make the answer very short. 0.89. What is the ratio of the Gross enrolment ratio (%) in Afghanistan in 1976 to that in 1978?
Your answer should be compact. 0.7. What is the ratio of the Gross enrolment ratio (%) of Egypt, Arab Rep. in 1976 to that in 1978?
Give a very brief answer. 0.85. What is the ratio of the Gross enrolment ratio (%) of European Union in 1977 to that in 1978?
Make the answer very short. 0.98. What is the ratio of the Gross enrolment ratio (%) in Fragile and conflict affected situations in 1977 to that in 1978?
Provide a succinct answer. 0.95. What is the ratio of the Gross enrolment ratio (%) of Afghanistan in 1977 to that in 1978?
Your answer should be compact. 0.78. What is the ratio of the Gross enrolment ratio (%) in Egypt, Arab Rep. in 1977 to that in 1978?
Provide a short and direct response. 0.96. What is the difference between the highest and the second highest Gross enrolment ratio (%) of European Union?
Keep it short and to the point. 0.5. What is the difference between the highest and the second highest Gross enrolment ratio (%) of Fragile and conflict affected situations?
Your answer should be very brief. 0.21. What is the difference between the highest and the second highest Gross enrolment ratio (%) in Afghanistan?
Keep it short and to the point. 0.39. What is the difference between the highest and the second highest Gross enrolment ratio (%) in Egypt, Arab Rep.?
Keep it short and to the point. 0.55. What is the difference between the highest and the lowest Gross enrolment ratio (%) in European Union?
Offer a terse response. 4.03. What is the difference between the highest and the lowest Gross enrolment ratio (%) in Fragile and conflict affected situations?
Your response must be concise. 0.83. What is the difference between the highest and the lowest Gross enrolment ratio (%) of Afghanistan?
Your answer should be very brief. 0.72. What is the difference between the highest and the lowest Gross enrolment ratio (%) in Egypt, Arab Rep.?
Make the answer very short. 6.35. 